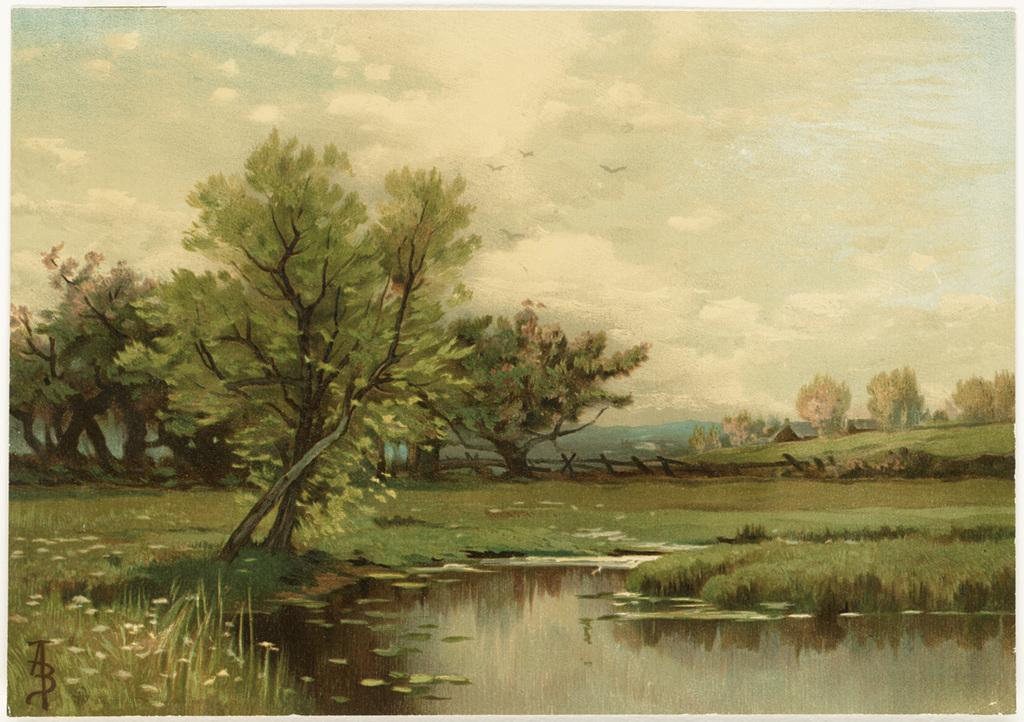What is the main subject of the image? The image contains a painting. What is the painting depicting? The painting depicts water. Are there any objects or elements floating on the water in the painting? Yes, there are leaves on the water in the painting. What other natural elements can be seen in the painting? There are trees and grass in the painting. What is visible in the background of the painting? The sky with clouds is visible in the background of the painting. What is the rate of the yard in the painting? There is no yard present in the painting, as it depicts water, leaves, trees, grass, and a sky with clouds. 